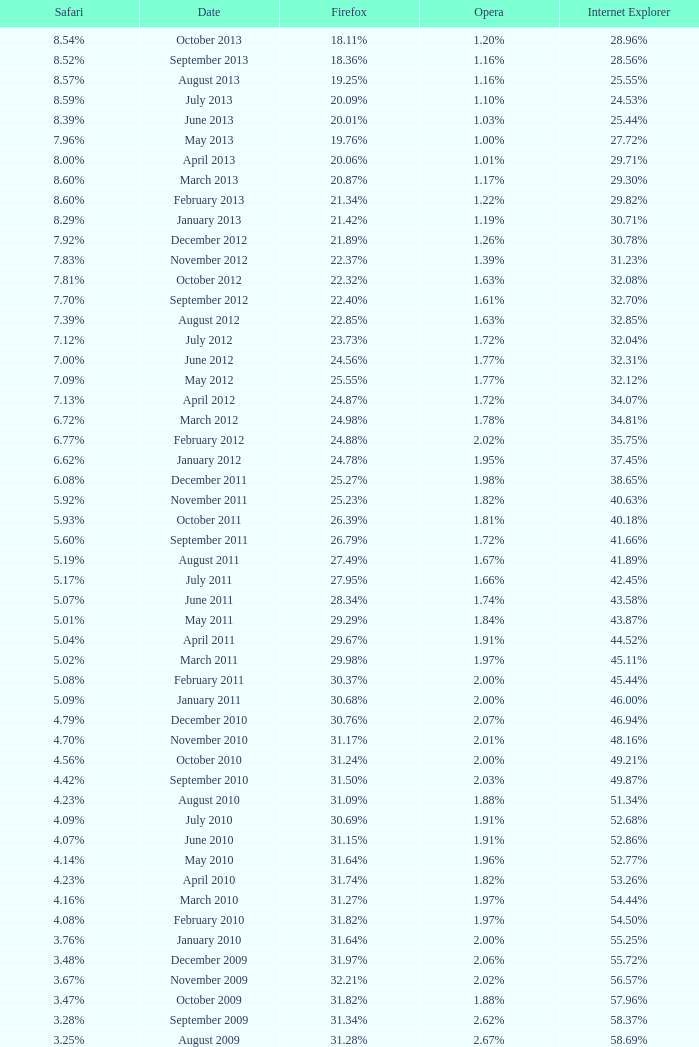What percentage of browsers were using Opera in November 2009? 2.02%. 